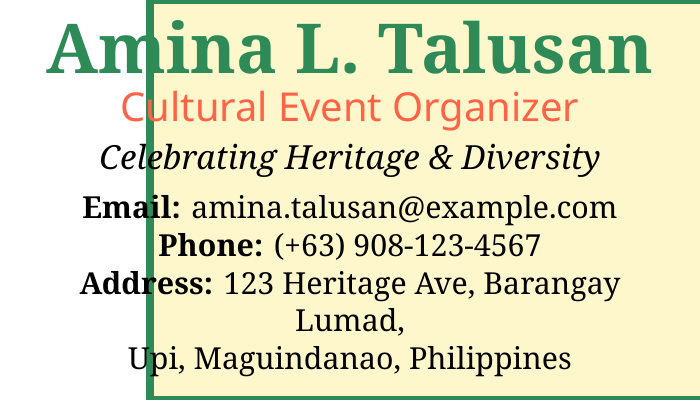What is the name on the card? The card displays the name "Amina L. Talusan."
Answer: Amina L. Talusan What is the title of the person? The card states the person's title as "Cultural Event Organizer."
Answer: Cultural Event Organizer What does the card celebrate? The card mentions "Celebrating Heritage & Diversity."
Answer: Celebrating Heritage & Diversity What is the email address listed? The card provides the email as "amina.talusan@example.com."
Answer: amina.talusan@example.com What is the phone number? The card lists the phone number as "(+63) 908-123-4567."
Answer: (+63) 908-123-4567 What is the address provided? The card shows the address as "123 Heritage Ave, Barangay Lumad, Upi, Maguindanao, Philippines."
Answer: 123 Heritage Ave, Barangay Lumad, Upi, Maguindanao, Philippines What color is used for the border on the card? The card indicates a border color of "greencolor."
Answer: greencolor How many symbols are included in the visuals? The visuals have three symbols displayed along the bottom of the card.
Answer: Three What is the main font used in the card? The card utilizes the "Noto Serif" font as the main font.
Answer: Noto Serif 